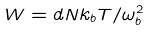Convert formula to latex. <formula><loc_0><loc_0><loc_500><loc_500>W = d N k _ { b } T / \omega _ { b } ^ { 2 }</formula> 